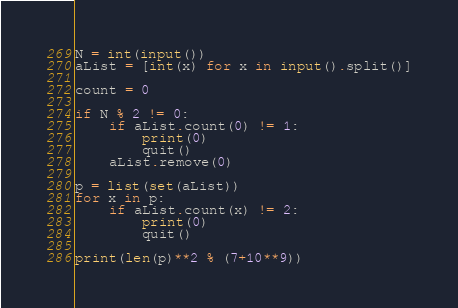<code> <loc_0><loc_0><loc_500><loc_500><_Python_>N = int(input())
aList = [int(x) for x in input().split()]

count = 0

if N % 2 != 0:
    if aList.count(0) != 1:
        print(0)
        quit()
    aList.remove(0)

p = list(set(aList))
for x in p:
    if aList.count(x) != 2:
        print(0)
        quit()

print(len(p)**2 % (7+10**9))</code> 